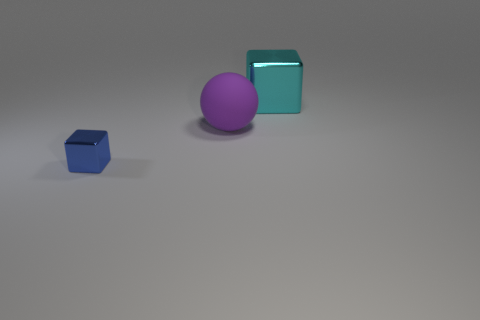Are there more large yellow shiny objects than cyan shiny blocks?
Provide a succinct answer. No. How many things are small blue blocks or things that are in front of the large shiny object?
Keep it short and to the point. 2. Do the blue metal thing and the matte ball have the same size?
Your response must be concise. No. There is a big purple rubber ball; are there any objects behind it?
Provide a succinct answer. Yes. What size is the object that is on the left side of the cyan cube and behind the blue thing?
Your answer should be very brief. Large. How many objects are either big purple matte objects or metal objects?
Provide a succinct answer. 3. Do the blue metallic object and the rubber thing on the left side of the cyan cube have the same size?
Give a very brief answer. No. What size is the shiny object in front of the shiny cube that is behind the shiny object in front of the cyan block?
Offer a terse response. Small. Are any tiny blue shiny things visible?
Your response must be concise. Yes. What number of rubber spheres have the same color as the large block?
Offer a very short reply. 0. 